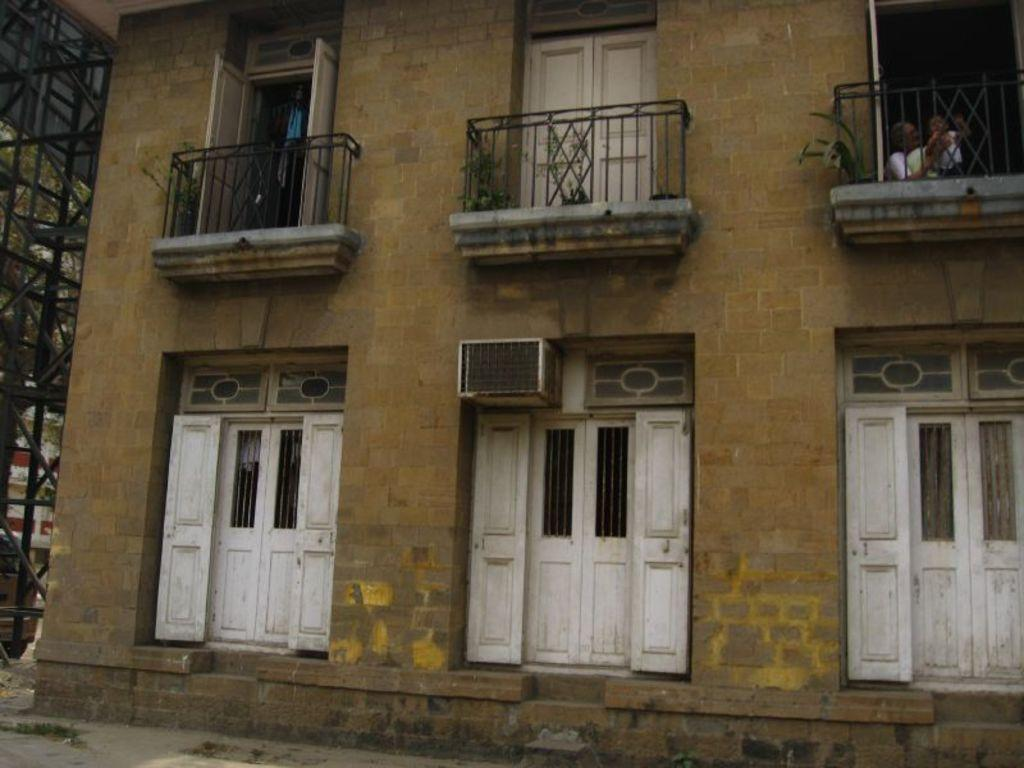What type of structure is present in the image? There is a building in the image. What features can be observed on the building? The building has windows and railings. Can you describe the people visible in the image? There is a woman and a baby visible behind the railing in the top right of the image. What other object can be seen in the image? There is a pole on the left side of the image. What type of iron is being used by the woman in the image? There is no iron present in the image; the woman is holding a baby behind the railing. What reward is the baby receiving for being low in the image? There is no reward being given, and the baby's position is not mentioned in the image. 